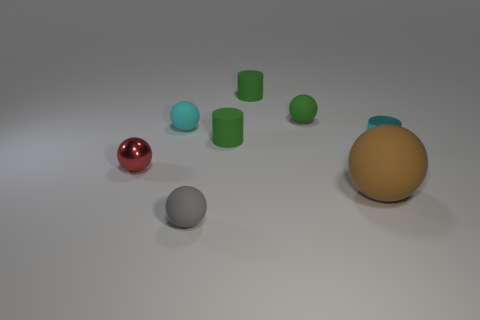Can you describe the colors and materials of the objects in this image? Certainly! The image presents a variety of objects with different colors and materials. There's a large peach-colored matte ball, a small glossy red ball, a medium-sized gray matte ball, and several small cyan rubber cylinders. They're all resting on a neutral surface with a soft shadow indicating a light source above them. 